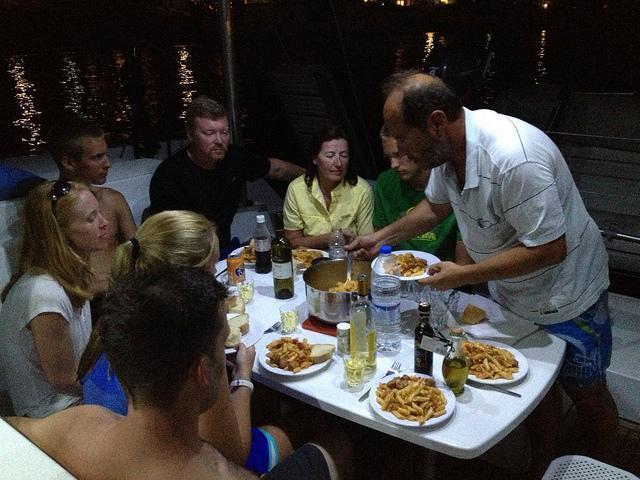How many women?
Give a very brief answer. 3. How many dining tables are in the photo?
Give a very brief answer. 1. How many people are there?
Give a very brief answer. 8. How many chairs don't have a dog on them?
Give a very brief answer. 0. 